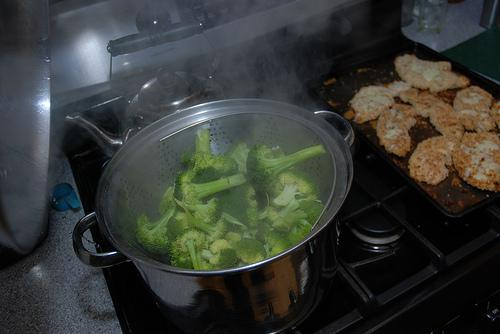Question: where was the photo taken?
Choices:
A. In the bedroom.
B. On a bed.
C. On the stove.
D. At the diner table.
Answer with the letter. Answer: C Question: what is there?
Choices:
A. Book.
B. Food.
C. Paper.
D. Pencils.
Answer with the letter. Answer: B Question: what is below the pot?
Choices:
A. The bowl.
B. The spoon.
C. The stove.
D. The fork.
Answer with the letter. Answer: C Question: how many pots are there?
Choices:
A. Two.
B. Zero.
C. Three.
D. One.
Answer with the letter. Answer: D 